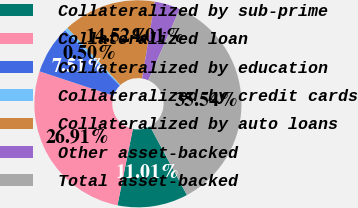<chart> <loc_0><loc_0><loc_500><loc_500><pie_chart><fcel>Collateralized by sub-prime<fcel>Collateralized loan<fcel>Collateralized by education<fcel>Collateralized by credit cards<fcel>Collateralized by auto loans<fcel>Other asset-backed<fcel>Total asset-backed<nl><fcel>11.01%<fcel>26.91%<fcel>7.51%<fcel>0.5%<fcel>14.52%<fcel>4.01%<fcel>35.54%<nl></chart> 